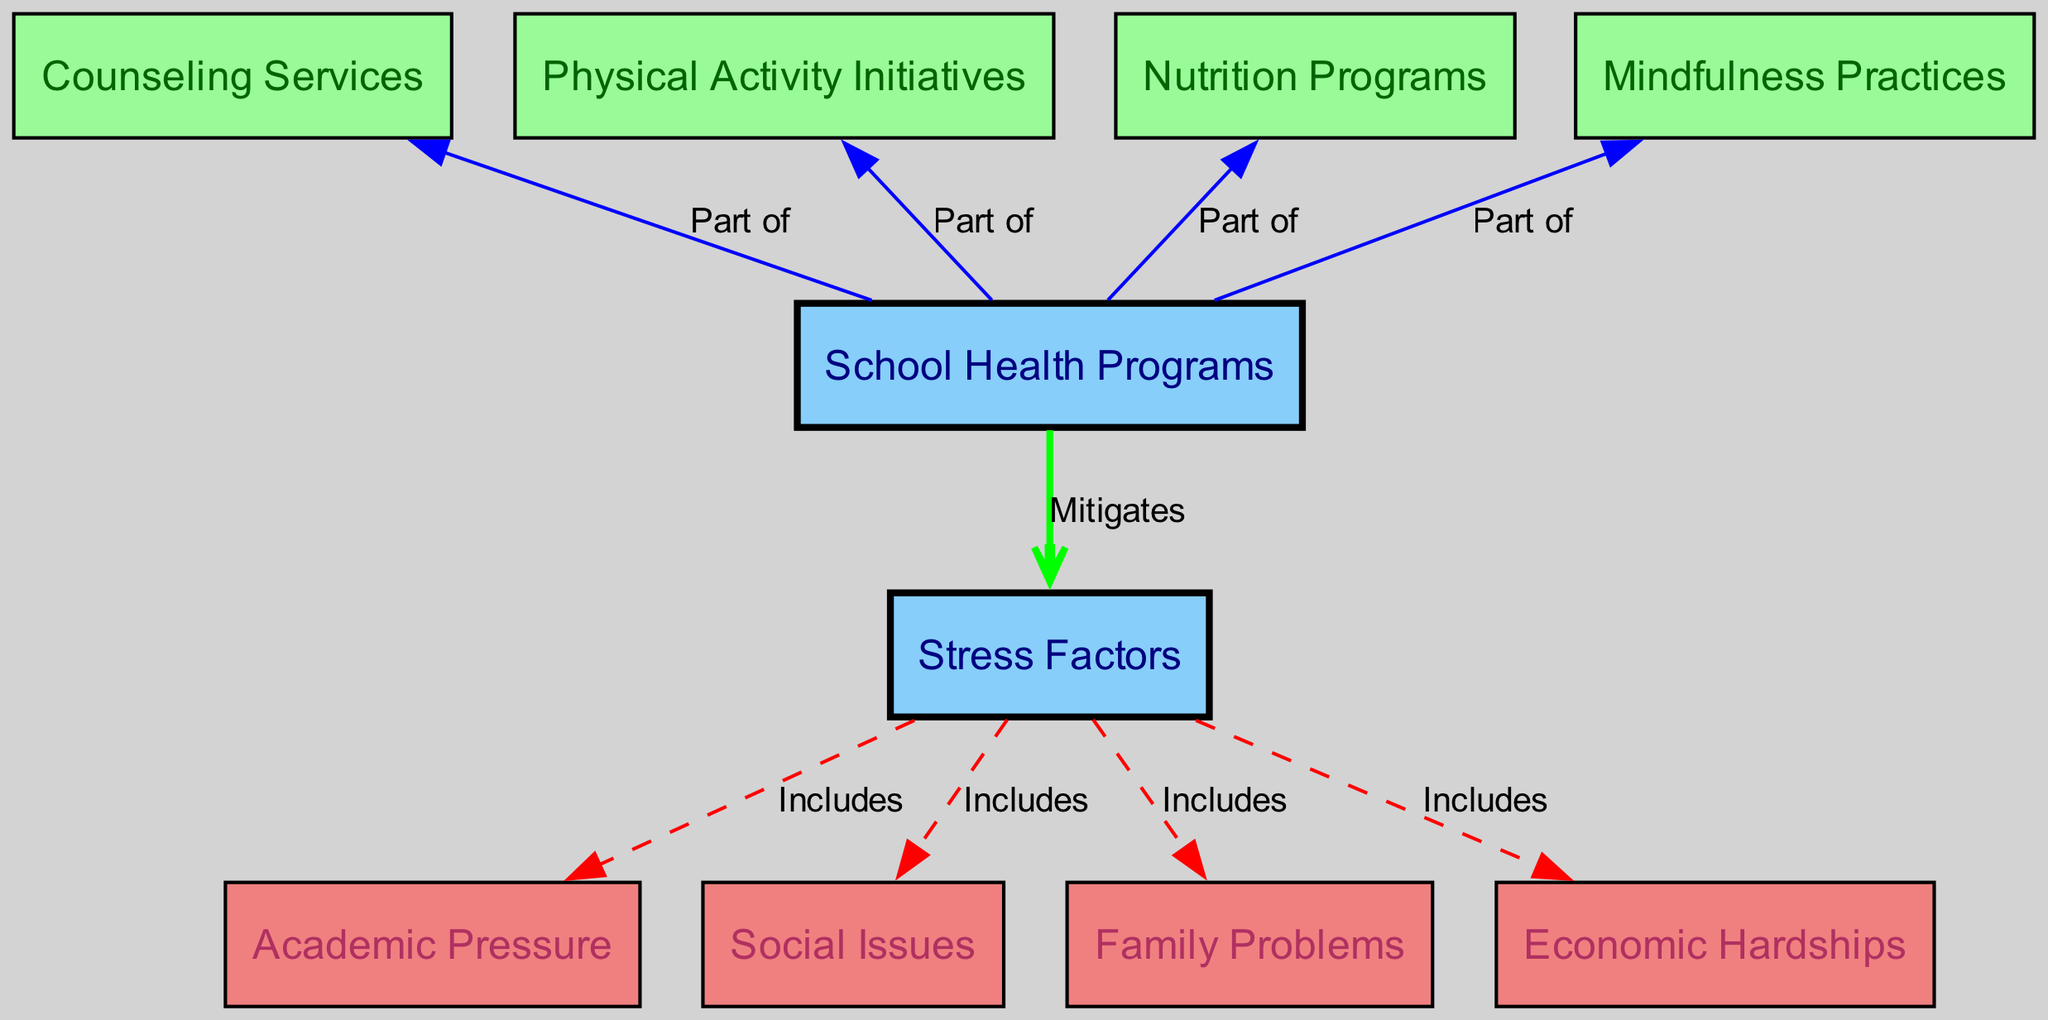What are the main categories represented in this diagram? The diagram has two main categories: 'Stress Factors' and 'School Health Programs.' These categories organize the various specific factors and programs associated with them.
Answer: Stress Factors, School Health Programs How many stress factors are included in the diagram? The diagram lists four specific stress factors under the 'Stress Factors' category. These are 'Academic Pressure,' 'Social Issues,' 'Family Problems,' and 'Economic Hardships.'
Answer: Four Which program is part of the 'School Health Programs' category? The programs under the 'School Health Programs' category include 'Counseling Services,' 'Physical Activity Initiatives,' 'Nutrition Programs,' and 'Mindfulness Practices.' All these programs aim to mitigate stress.
Answer: Counseling Services What relationship is shown between 'Stress Factors' and 'School Health Programs'? The diagram indicates that 'School Health Programs' mitigates the 'Stress Factors,' which means these programs are designed to reduce or alleviate various stress factors affecting students.
Answer: Mitigates Which specific stress factor is connected to 'Family Problems'? The edge implies that 'Family Problems' is a stress factor included within the broader category of 'Stress Factors.' It specifically receives its recognition among other factors like academic and social issues.
Answer: Family Problems How many programs are linked back to the 'School Health Programs' category? There are four programs linked back to the 'School Health Programs' category: 'Counseling Services,' 'Physical Activity Initiatives,' 'Nutrition Programs,' and 'Mindfulness Practices,' all contributing to student well-being.
Answer: Four Which factors are included under 'Stress Factors'? The factors included are 'Academic Pressure,' 'Social Issues,' 'Family Problems,' and 'Economic Hardships.' These illustrate the different challenges students may face that could lead to stress.
Answer: Academic Pressure, Social Issues, Family Problems, Economic Hardships Which program directly addresses mental health among students? 'Counseling Services' is a program that specifically addresses mental health, providing support and strategies to help students cope with stressors effectively.
Answer: Counseling Services 